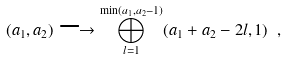<formula> <loc_0><loc_0><loc_500><loc_500>( a _ { 1 } , a _ { 2 } ) \longrightarrow \bigoplus _ { l = 1 } ^ { \min ( a _ { 1 } , a _ { 2 } - 1 ) } ( a _ { 1 } + a _ { 2 } - 2 l , 1 ) \ ,</formula> 